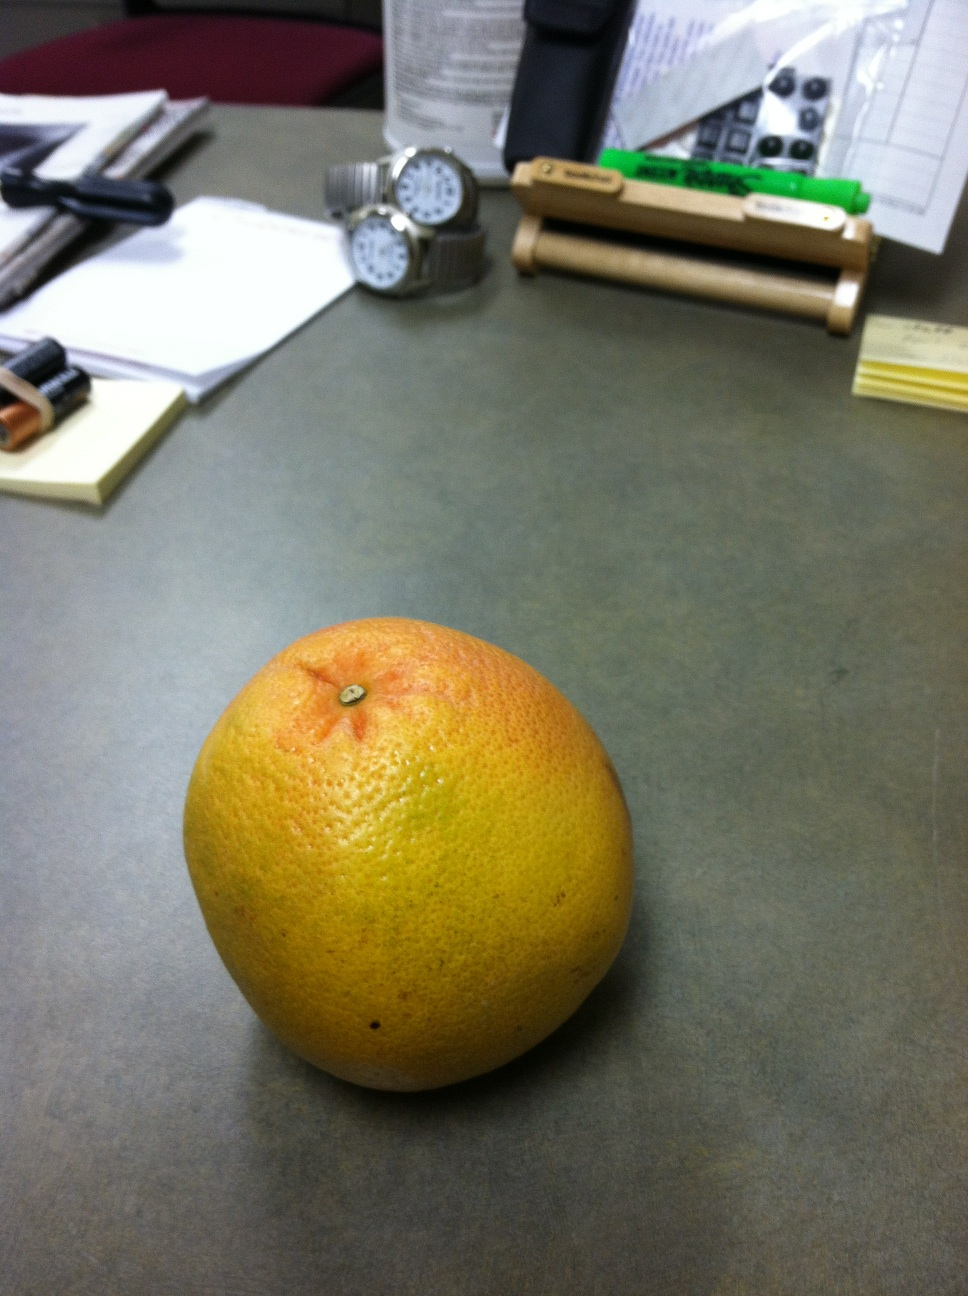What color is this? from Vizwiz orange 